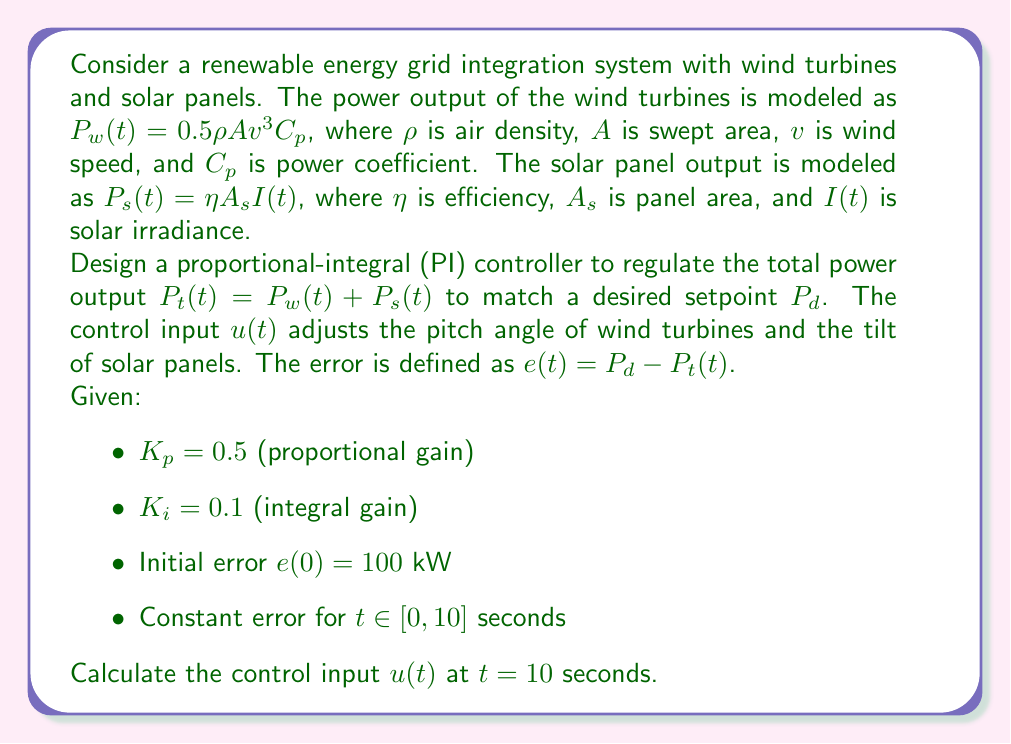Give your solution to this math problem. To solve this problem, we need to use the equation for a PI controller and integrate the error over time. The steps are as follows:

1) The general form of a PI controller is:

   $$u(t) = K_p e(t) + K_i \int_0^t e(\tau) d\tau$$

2) We're given that the error is constant for the first 10 seconds, so:

   $$e(t) = e(0) = 100 \text{ kW for } t \in [0, 10]$$

3) Now we can calculate the integral term:

   $$\int_0^t e(\tau) d\tau = \int_0^{10} 100 d\tau = 100t|_0^{10} = 1000 \text{ kW⋅s}$$

4) Substituting the values into the PI controller equation:

   $$u(10) = K_p e(10) + K_i \int_0^{10} e(\tau) d\tau$$
   $$u(10) = 0.5 \cdot 100 + 0.1 \cdot 1000$$
   $$u(10) = 50 + 100$$
   $$u(10) = 150$$

The units of the control input $u(t)$ depend on how it's implemented in the system, but it's typically dimensionless or in degrees for pitch/tilt angles.
Answer: $u(10) = 150$ 